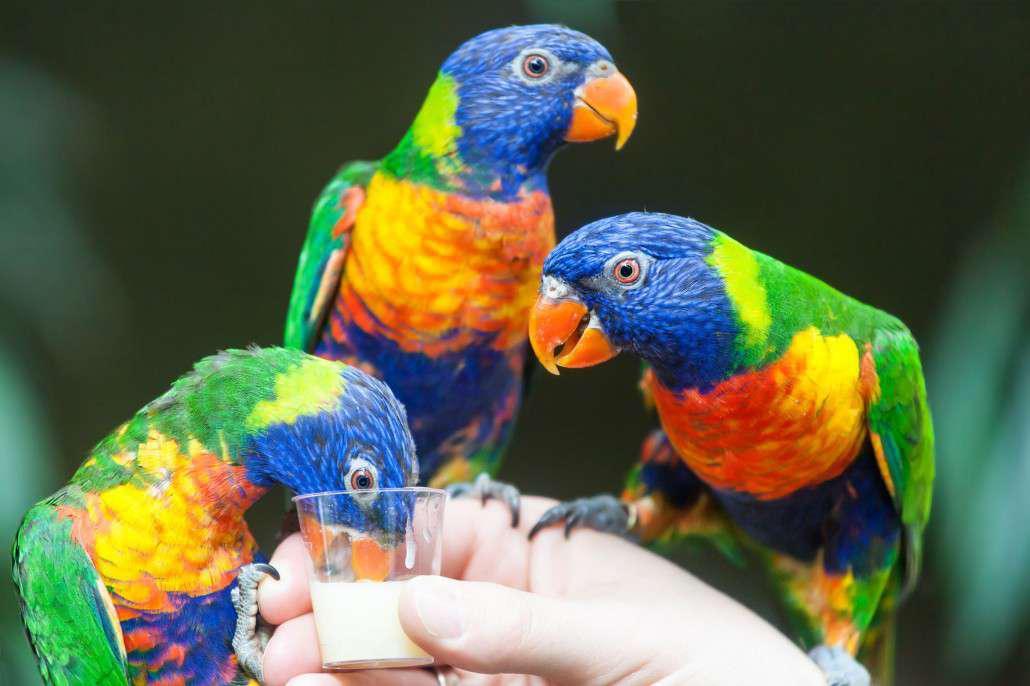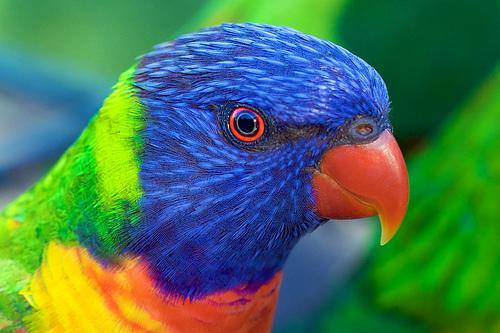The first image is the image on the left, the second image is the image on the right. Evaluate the accuracy of this statement regarding the images: "A human hand is offering food to birds in the left image.". Is it true? Answer yes or no. Yes. 